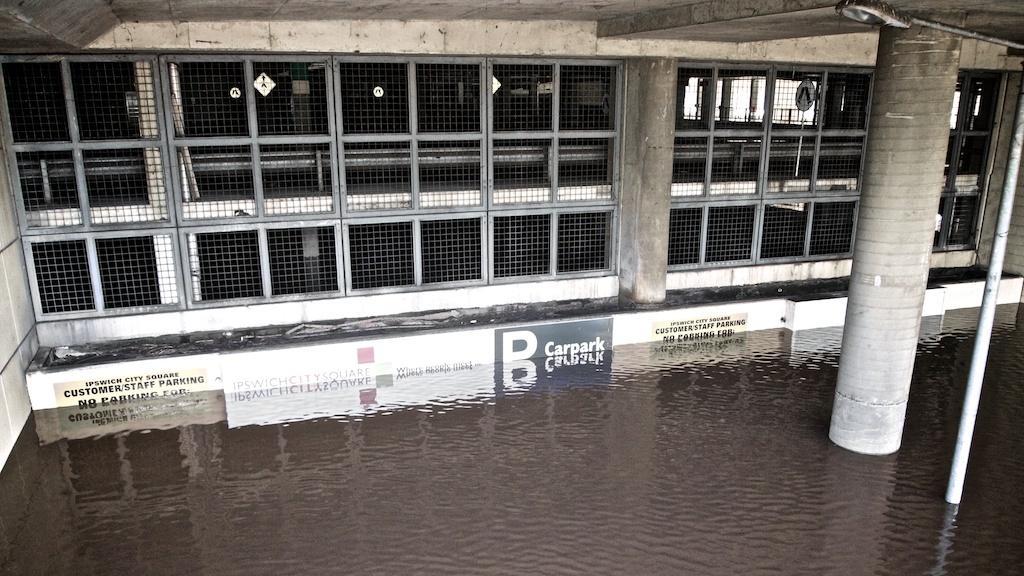Could you give a brief overview of what you see in this image? At the bottom there is water. On the right there is a pillar and there is a pole. In the background there is iron mesh. At the top it is ceiling. In the background towards right there are windows. 